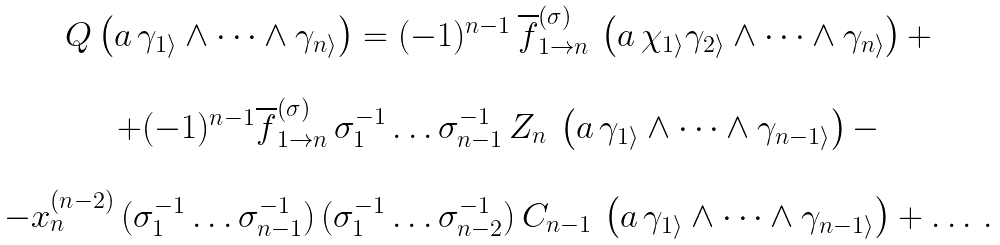Convert formula to latex. <formula><loc_0><loc_0><loc_500><loc_500>\begin{array} { c } Q \left ( a \, \gamma _ { 1 \rangle } \wedge \dots \wedge \gamma _ { n \rangle } \right ) = ( - 1 ) ^ { n - 1 } \, \overline { f } ^ { ( \sigma ) } _ { 1 \to n } \, \left ( a \, \chi _ { 1 \rangle } \gamma _ { 2 \rangle } \wedge \dots \wedge \gamma _ { n \rangle } \right ) + \\ \\ + ( - 1 ) ^ { n - 1 } \overline { f } ^ { ( \sigma ) } _ { 1 \to n } \, \sigma ^ { - 1 } _ { 1 } \dots \sigma ^ { - 1 } _ { n - 1 } \, Z _ { n } \, \left ( a \, \gamma _ { 1 \rangle } \wedge \dots \wedge \gamma _ { n - 1 \rangle } \right ) - \\ \\ - x ^ { ( n - 2 ) } _ { n } \, ( \sigma ^ { - 1 } _ { 1 } \dots \sigma ^ { - 1 } _ { n - 1 } ) \, ( \sigma ^ { - 1 } _ { 1 } \dots \sigma ^ { - 1 } _ { n - 2 } ) \, C _ { n - 1 } \, \left ( a \, \gamma _ { 1 \rangle } \wedge \dots \wedge \gamma _ { n - 1 \rangle } \right ) + \dots \, . \end{array}</formula> 